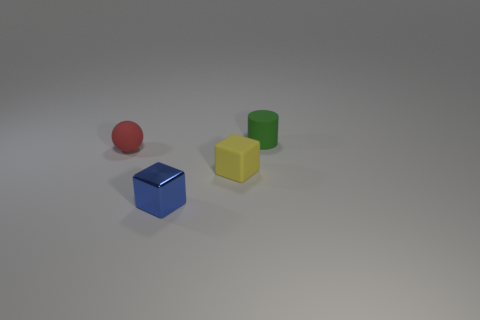Add 1 blue cubes. How many objects exist? 5 Subtract 0 brown cylinders. How many objects are left? 4 Subtract all cylinders. How many objects are left? 3 Subtract all brown balls. Subtract all gray cubes. How many balls are left? 1 Subtract all rubber balls. Subtract all yellow things. How many objects are left? 2 Add 1 shiny things. How many shiny things are left? 2 Add 1 spheres. How many spheres exist? 2 